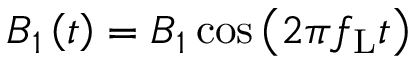Convert formula to latex. <formula><loc_0><loc_0><loc_500><loc_500>B _ { 1 } \left ( t \right ) = B _ { 1 } \cos \left ( 2 \pi f _ { L } t \right )</formula> 